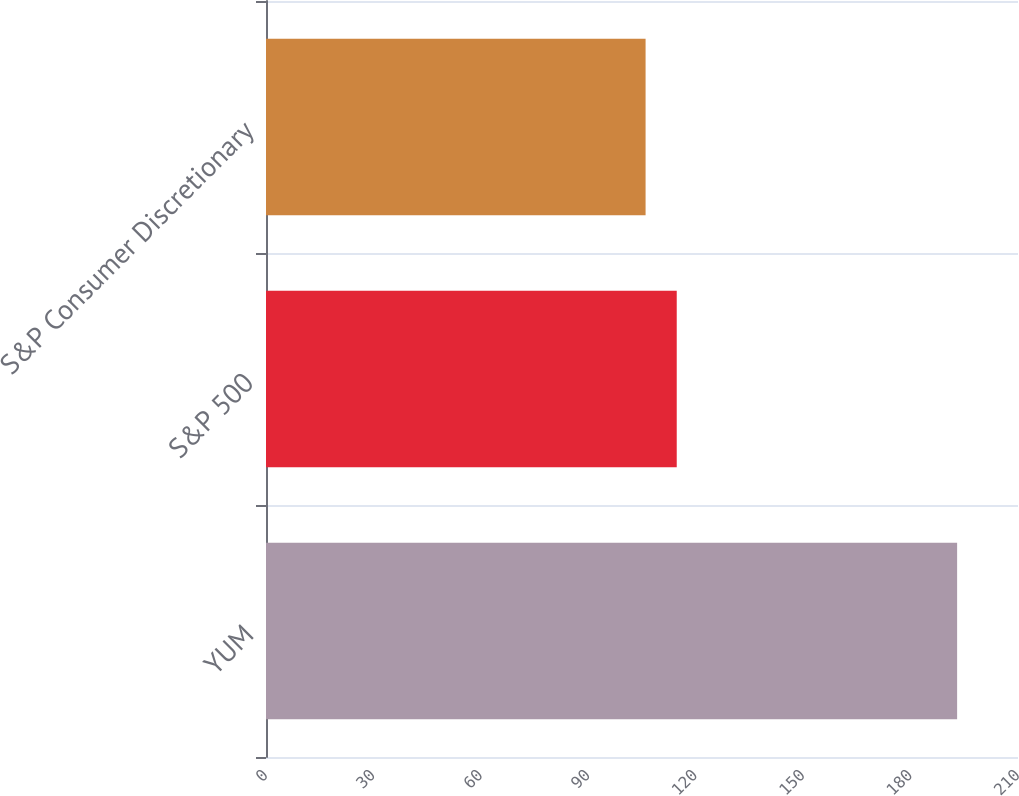Convert chart to OTSL. <chart><loc_0><loc_0><loc_500><loc_500><bar_chart><fcel>YUM<fcel>S&P 500<fcel>S&P Consumer Discretionary<nl><fcel>193<fcel>114.7<fcel>106<nl></chart> 